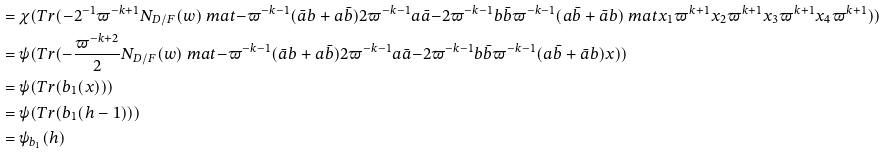Convert formula to latex. <formula><loc_0><loc_0><loc_500><loc_500>& = \chi ( T r ( - 2 ^ { - 1 } \varpi ^ { - k + 1 } N _ { D / F } ( w ) \ m a t { - \varpi ^ { - k - 1 } ( \bar { a } b + a \bar { b } ) } { 2 \varpi ^ { - k - 1 } a \bar { a } } { - 2 \varpi ^ { - k - 1 } b \bar { b } } { \varpi ^ { - k - 1 } ( a \bar { b } + \bar { a } b ) } \ m a t { x _ { 1 } \varpi ^ { k + 1 } } { x _ { 2 } \varpi ^ { k + 1 } } { x _ { 3 } \varpi ^ { k + 1 } } { x _ { 4 } \varpi ^ { k + 1 } } ) ) \\ & = \psi ( T r ( - \frac { \varpi ^ { - k + 2 } } { 2 } N _ { D / F } ( w ) \ m a t { - \varpi ^ { - k - 1 } ( \bar { a } b + a \bar { b } ) } { 2 \varpi ^ { - k - 1 } a \bar { a } } { - 2 \varpi ^ { - k - 1 } b \bar { b } } { \varpi ^ { - k - 1 } ( a \bar { b } + \bar { a } b ) } x ) ) \\ & = \psi ( T r ( b _ { 1 } ( x ) ) ) \\ & = \psi ( T r ( b _ { 1 } ( h - 1 ) ) ) \\ & = \psi _ { b _ { 1 } } ( h )</formula> 